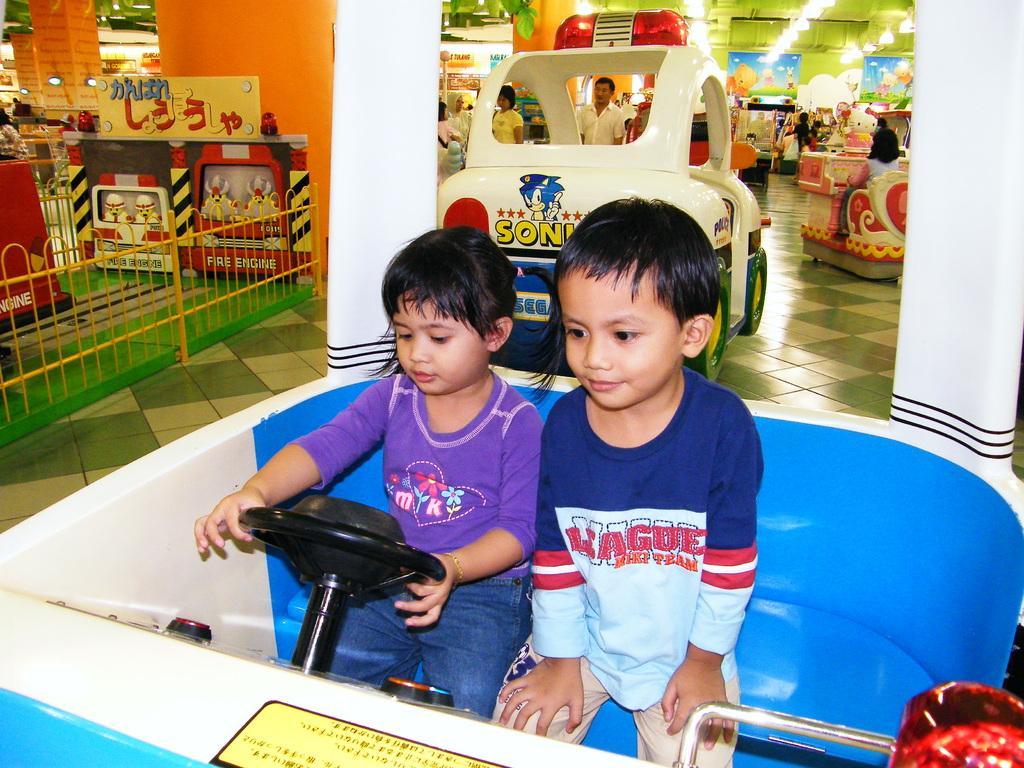Can you describe this image briefly? In this picture there are children in the center of the image inside a toy car and there are people, posters, lights, and gaming equipment in the background area. 